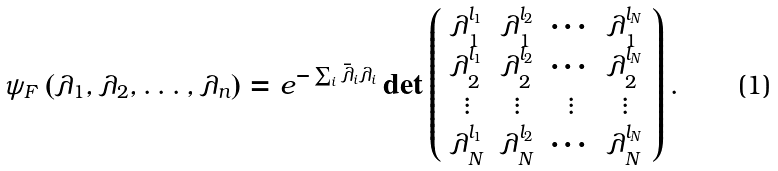<formula> <loc_0><loc_0><loc_500><loc_500>\psi _ { F } \left ( \lambda _ { 1 } , \lambda _ { 2 } , \dots , \lambda _ { n } \right ) = e ^ { - \sum _ { i } \bar { \lambda } _ { i } \lambda _ { i } } \det \left ( \begin{array} { c c c c } \lambda ^ { l _ { 1 } } _ { 1 } & \lambda ^ { l _ { 2 } } _ { 1 } & \cdots & \lambda ^ { l _ { N } } _ { 1 } \\ \lambda ^ { l _ { 1 } } _ { 2 } & \lambda ^ { l _ { 2 } } _ { 2 } & \cdots & \lambda ^ { l _ { N } } _ { 2 } \\ \vdots & \vdots & \vdots & \vdots \\ \lambda ^ { l _ { 1 } } _ { N } & \lambda ^ { l _ { 2 } } _ { N } & \cdots & \lambda ^ { l _ { N } } _ { N } \end{array} \right ) .</formula> 